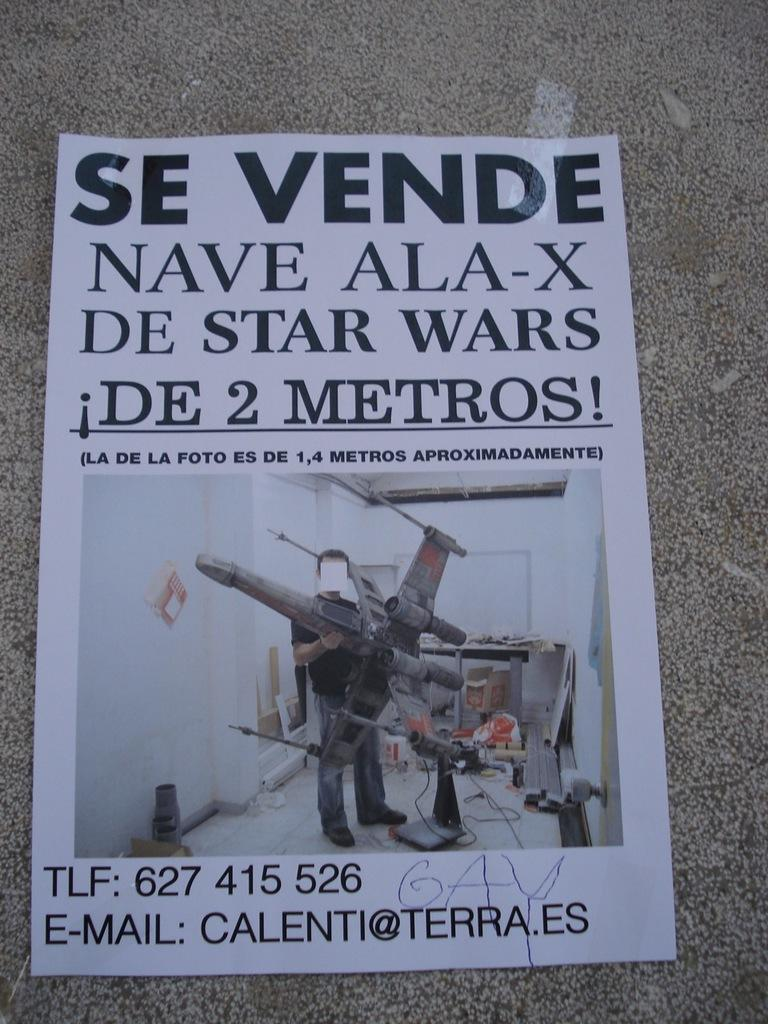<image>
Render a clear and concise summary of the photo. An ad has a phone number and contact email of calenti@terra.es. 